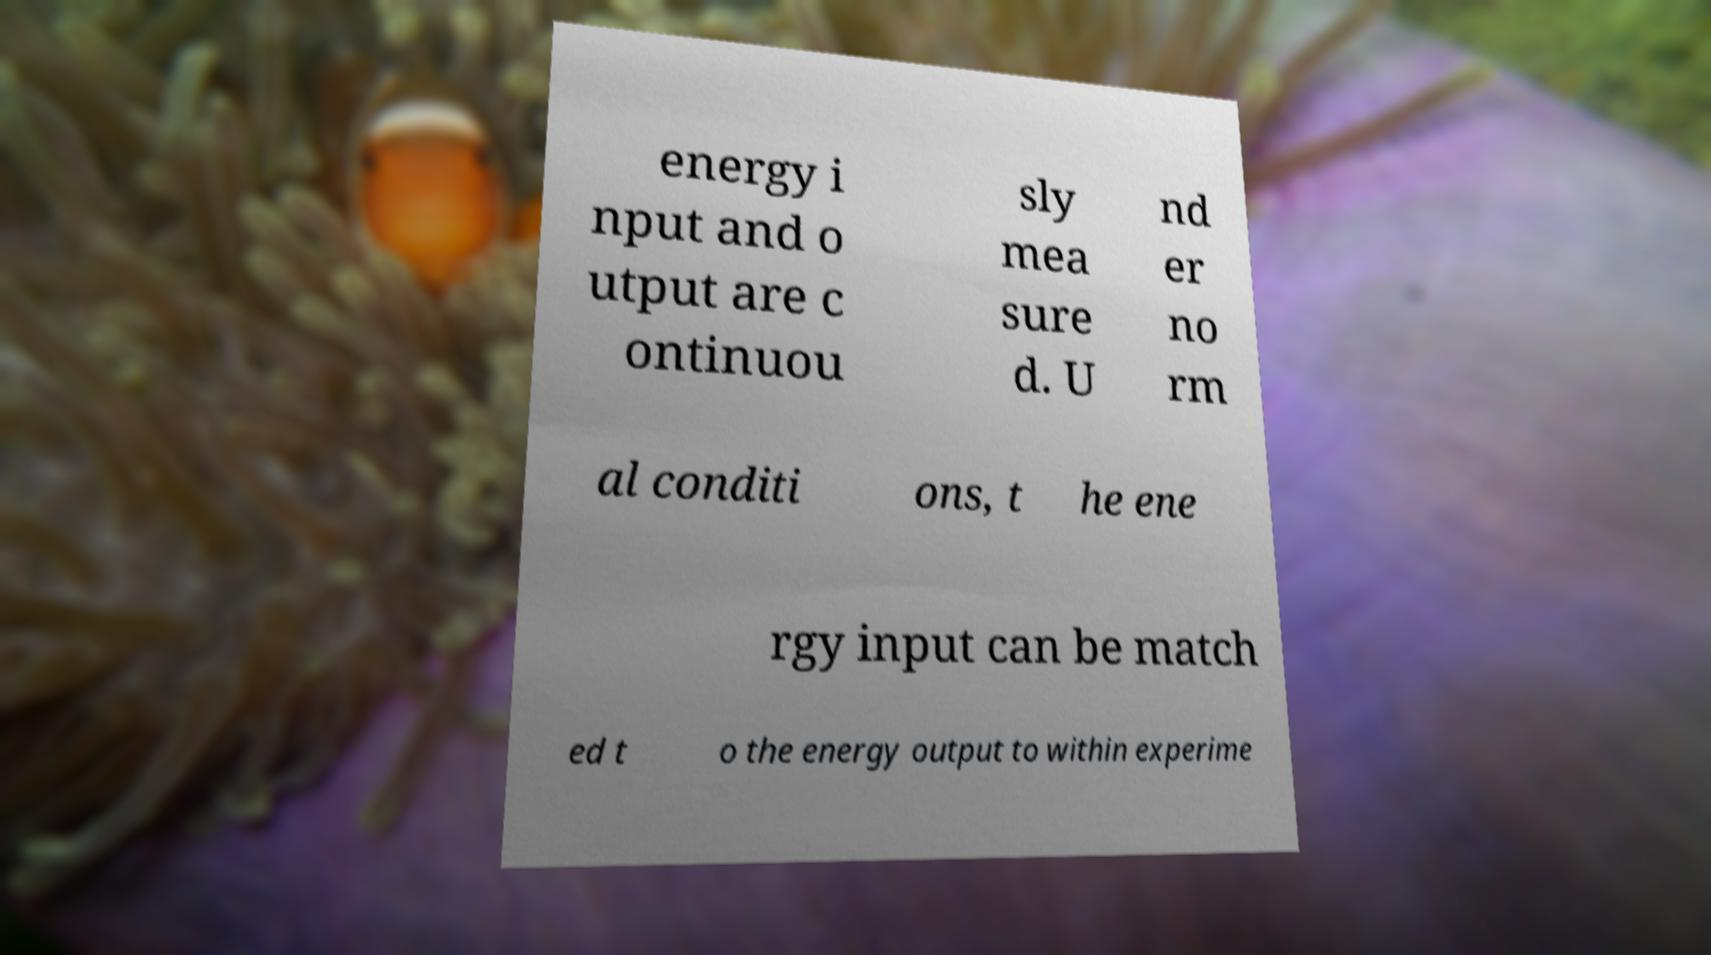What messages or text are displayed in this image? I need them in a readable, typed format. energy i nput and o utput are c ontinuou sly mea sure d. U nd er no rm al conditi ons, t he ene rgy input can be match ed t o the energy output to within experime 